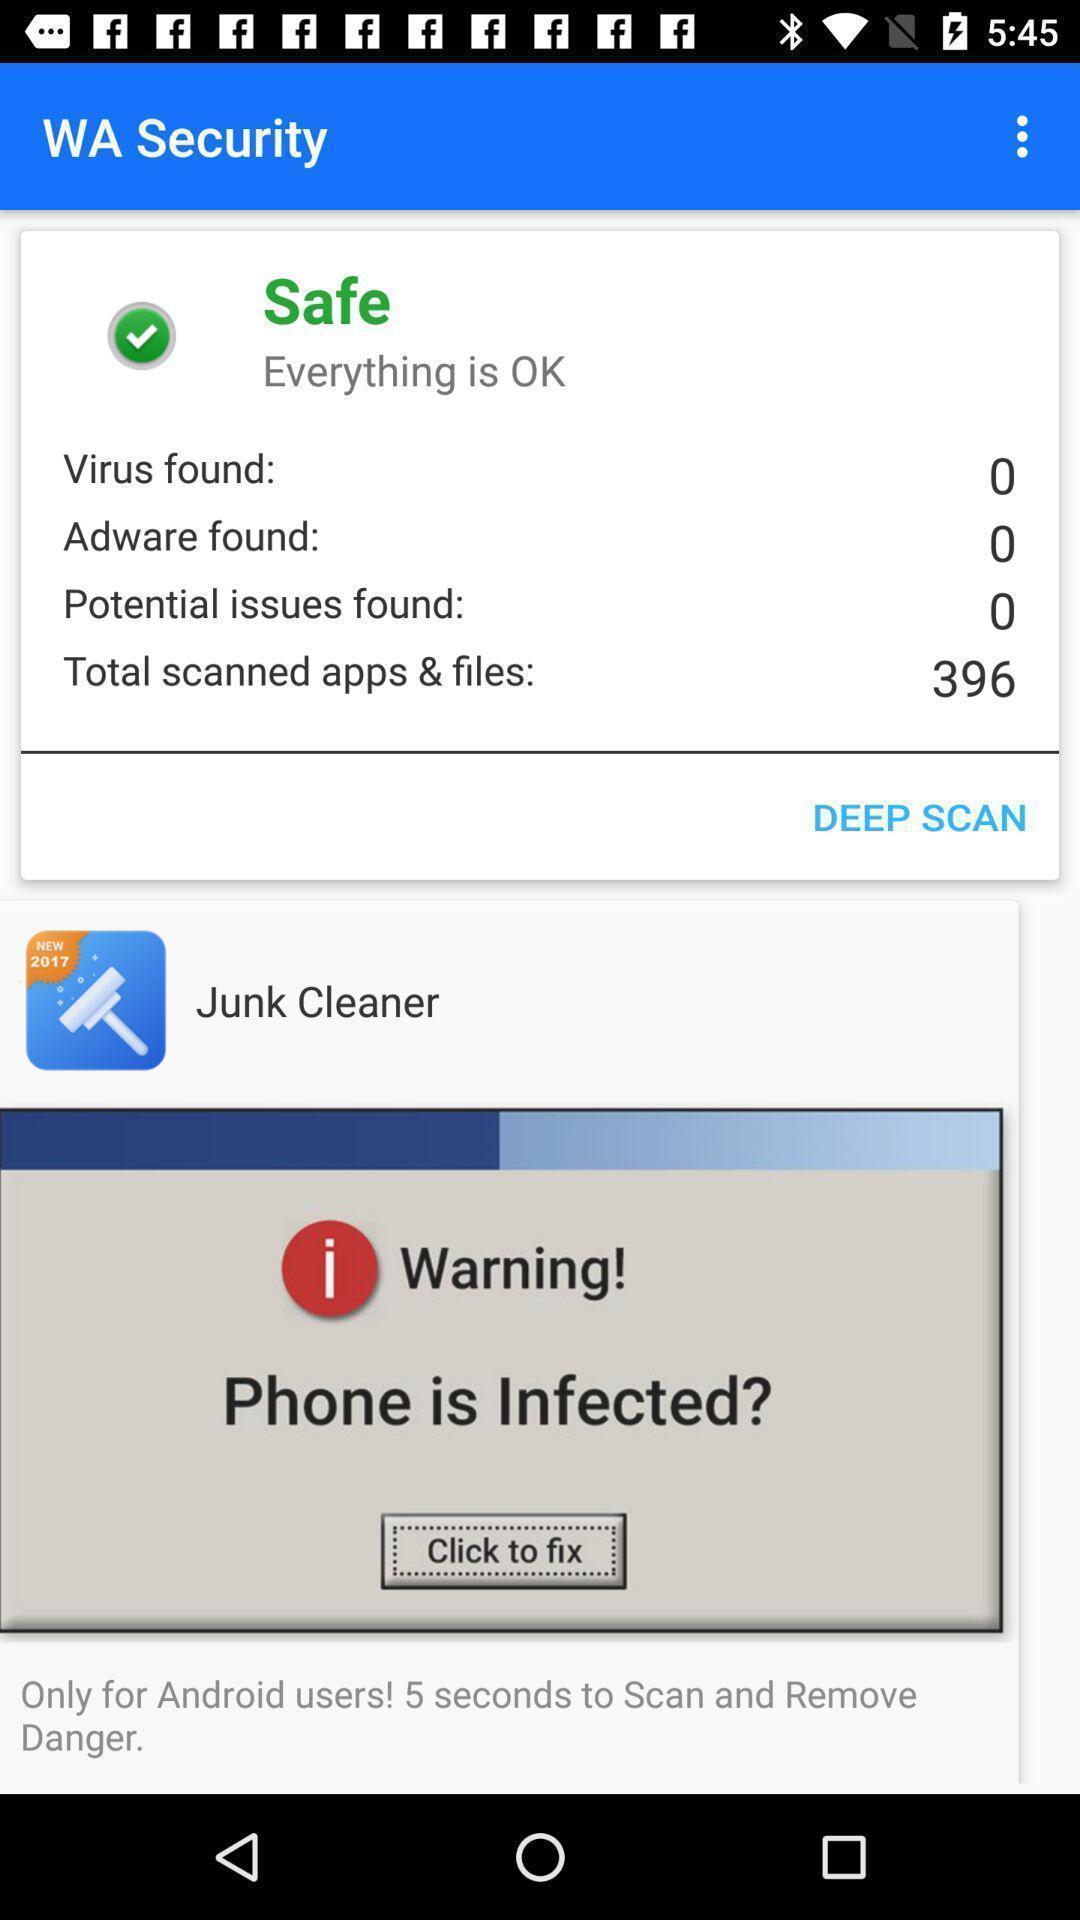Summarize the main components in this picture. Pop up page showing the warning error. 